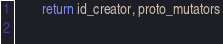<code> <loc_0><loc_0><loc_500><loc_500><_Python_>
        return id_creator, proto_mutators
        </code> 